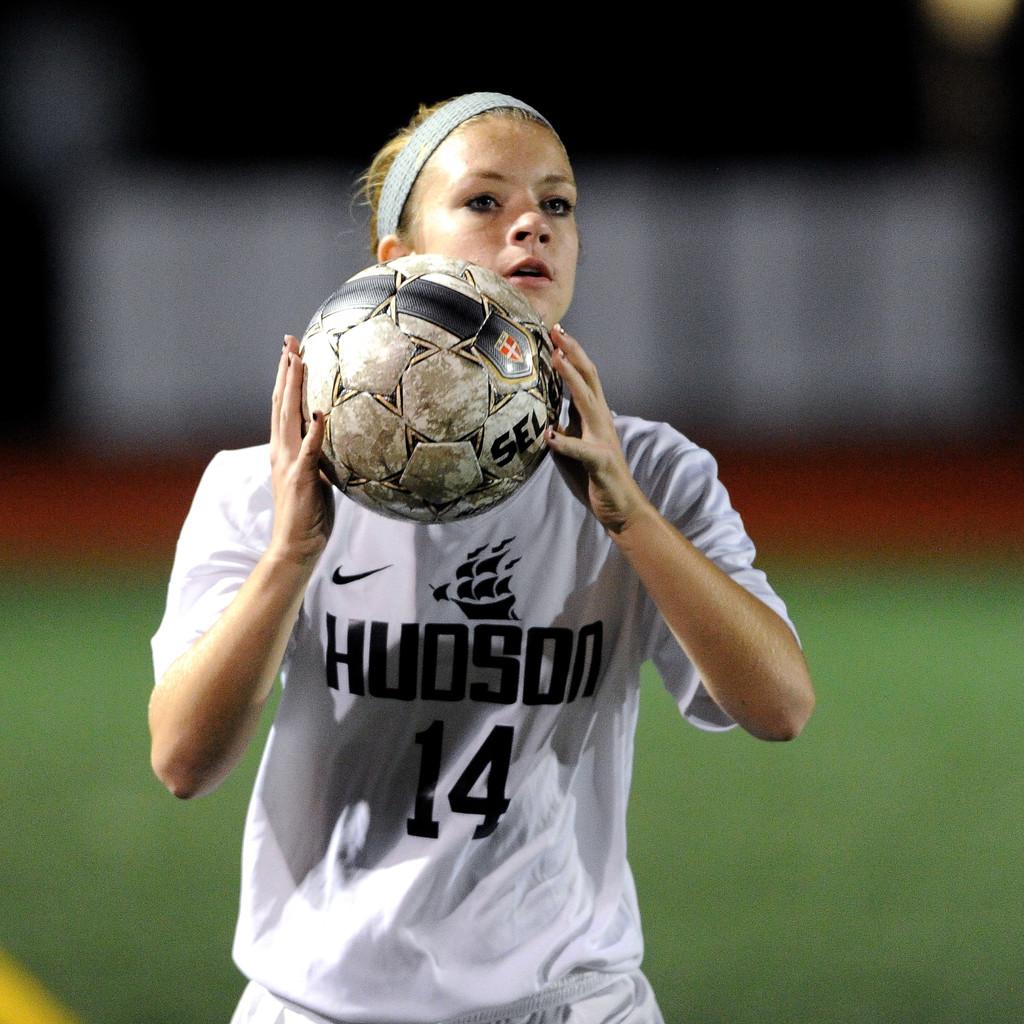What number is on the shirt?
Offer a very short reply. 14. What is the name of the team on her shirt?
Your response must be concise. Hudson. 